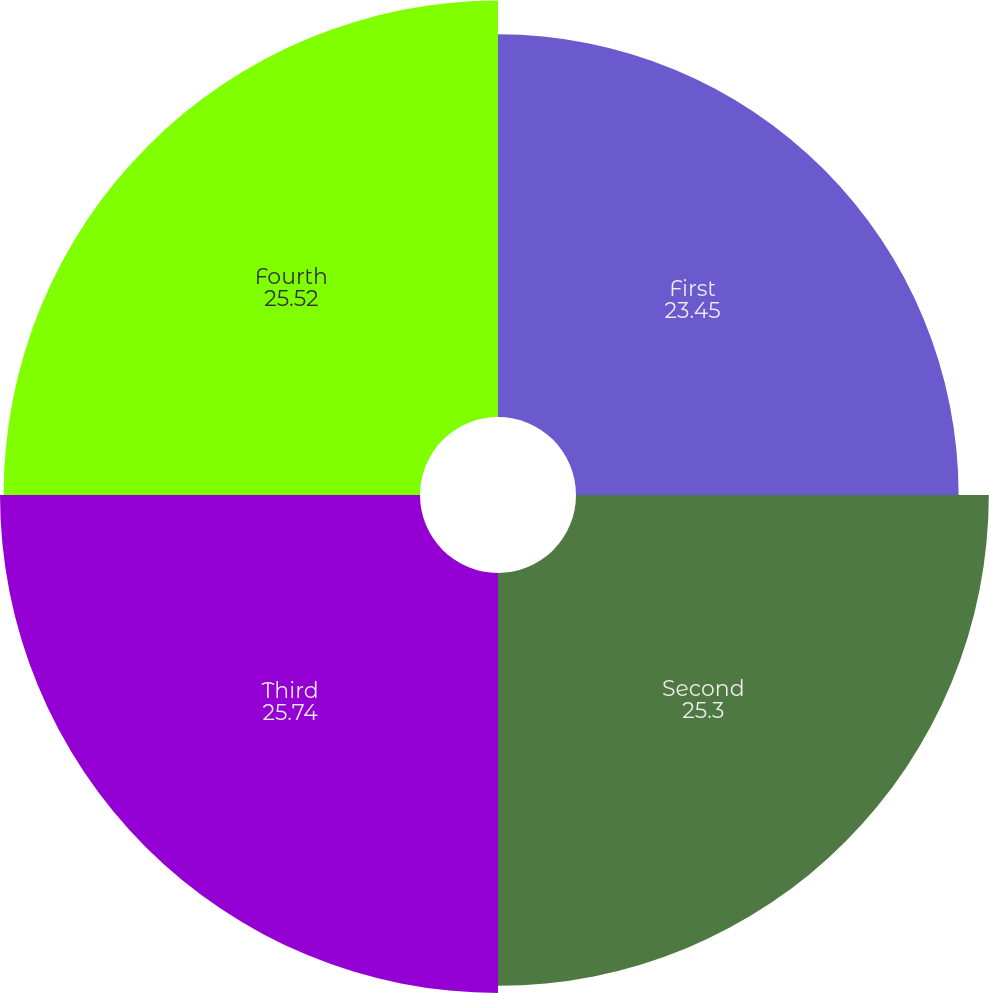<chart> <loc_0><loc_0><loc_500><loc_500><pie_chart><fcel>First<fcel>Second<fcel>Third<fcel>Fourth<nl><fcel>23.45%<fcel>25.3%<fcel>25.74%<fcel>25.52%<nl></chart> 